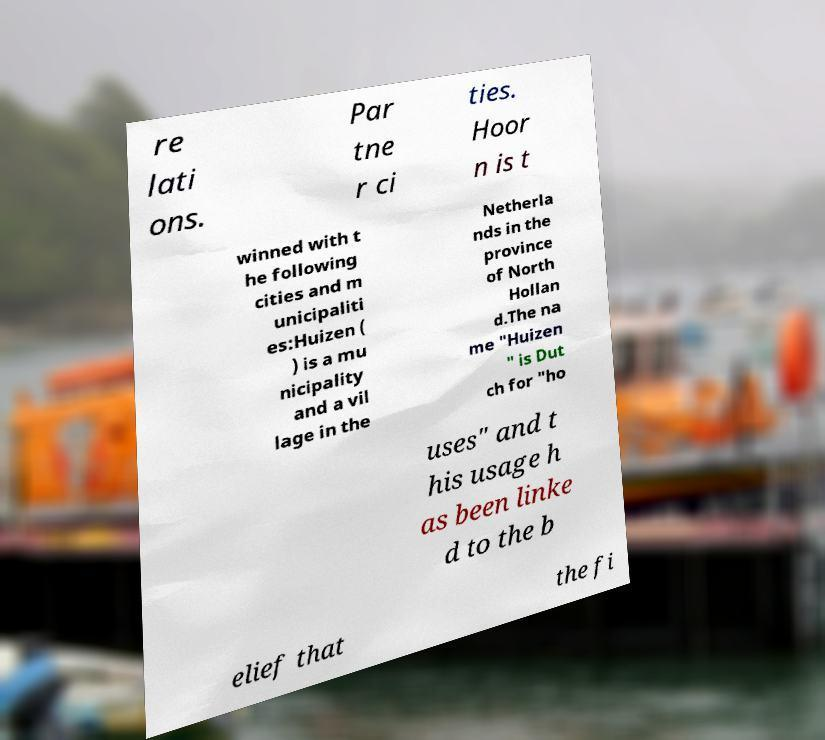For documentation purposes, I need the text within this image transcribed. Could you provide that? re lati ons. Par tne r ci ties. Hoor n is t winned with t he following cities and m unicipaliti es:Huizen ( ) is a mu nicipality and a vil lage in the Netherla nds in the province of North Hollan d.The na me "Huizen " is Dut ch for "ho uses" and t his usage h as been linke d to the b elief that the fi 